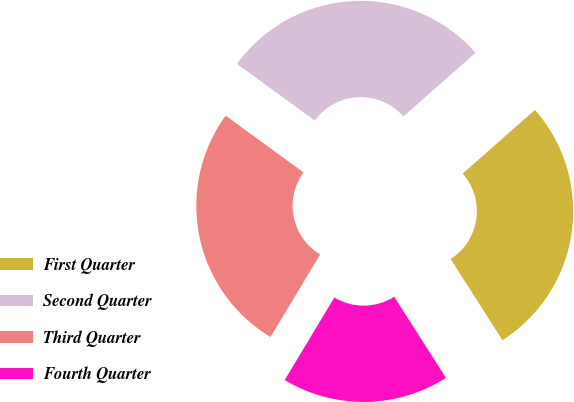<chart> <loc_0><loc_0><loc_500><loc_500><pie_chart><fcel>First Quarter<fcel>Second Quarter<fcel>Third Quarter<fcel>Fourth Quarter<nl><fcel>27.45%<fcel>28.49%<fcel>26.4%<fcel>17.66%<nl></chart> 